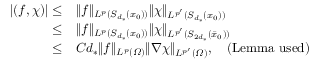Convert formula to latex. <formula><loc_0><loc_0><loc_500><loc_500>\begin{array} { r l } { | ( f , \chi ) | \leq } & { \| f \| _ { L ^ { p } ( S _ { d _ { * } } ( x _ { 0 } ) ) } \| \chi \| _ { L ^ { p ^ { \prime } } ( S _ { d _ { * } } ( x _ { 0 } ) ) } } \\ { \leq } & { \| f \| _ { L ^ { p } ( S _ { d _ { * } } ( x _ { 0 } ) ) } \| \chi \| _ { L ^ { p ^ { \prime } } ( S _ { 2 d _ { * } } ( \bar { x } _ { 0 } ) ) } } \\ { \leq } & { C d _ { * } \| f \| _ { L ^ { p } ( \varOmega ) } \| \nabla \chi \| _ { L ^ { p ^ { \prime } } ( \varOmega ) } , \quad ( L e m m a u s e d ) } \end{array}</formula> 